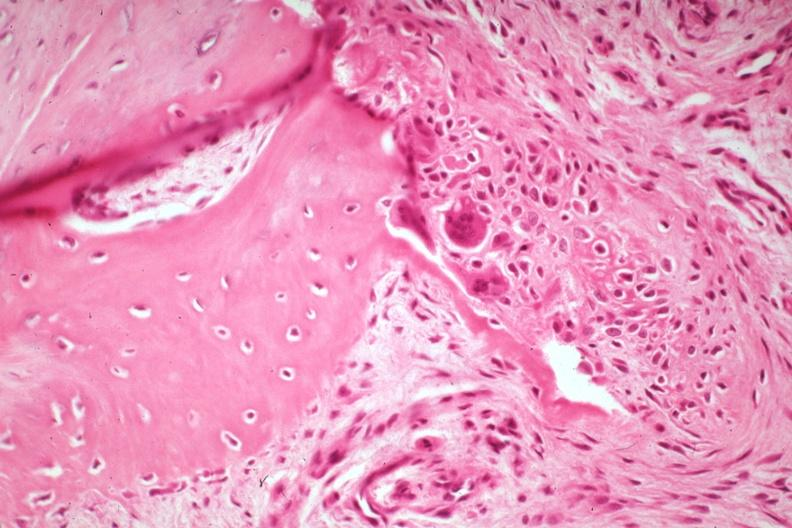what is there?
Answer the question using a single word or phrase. A fracture 